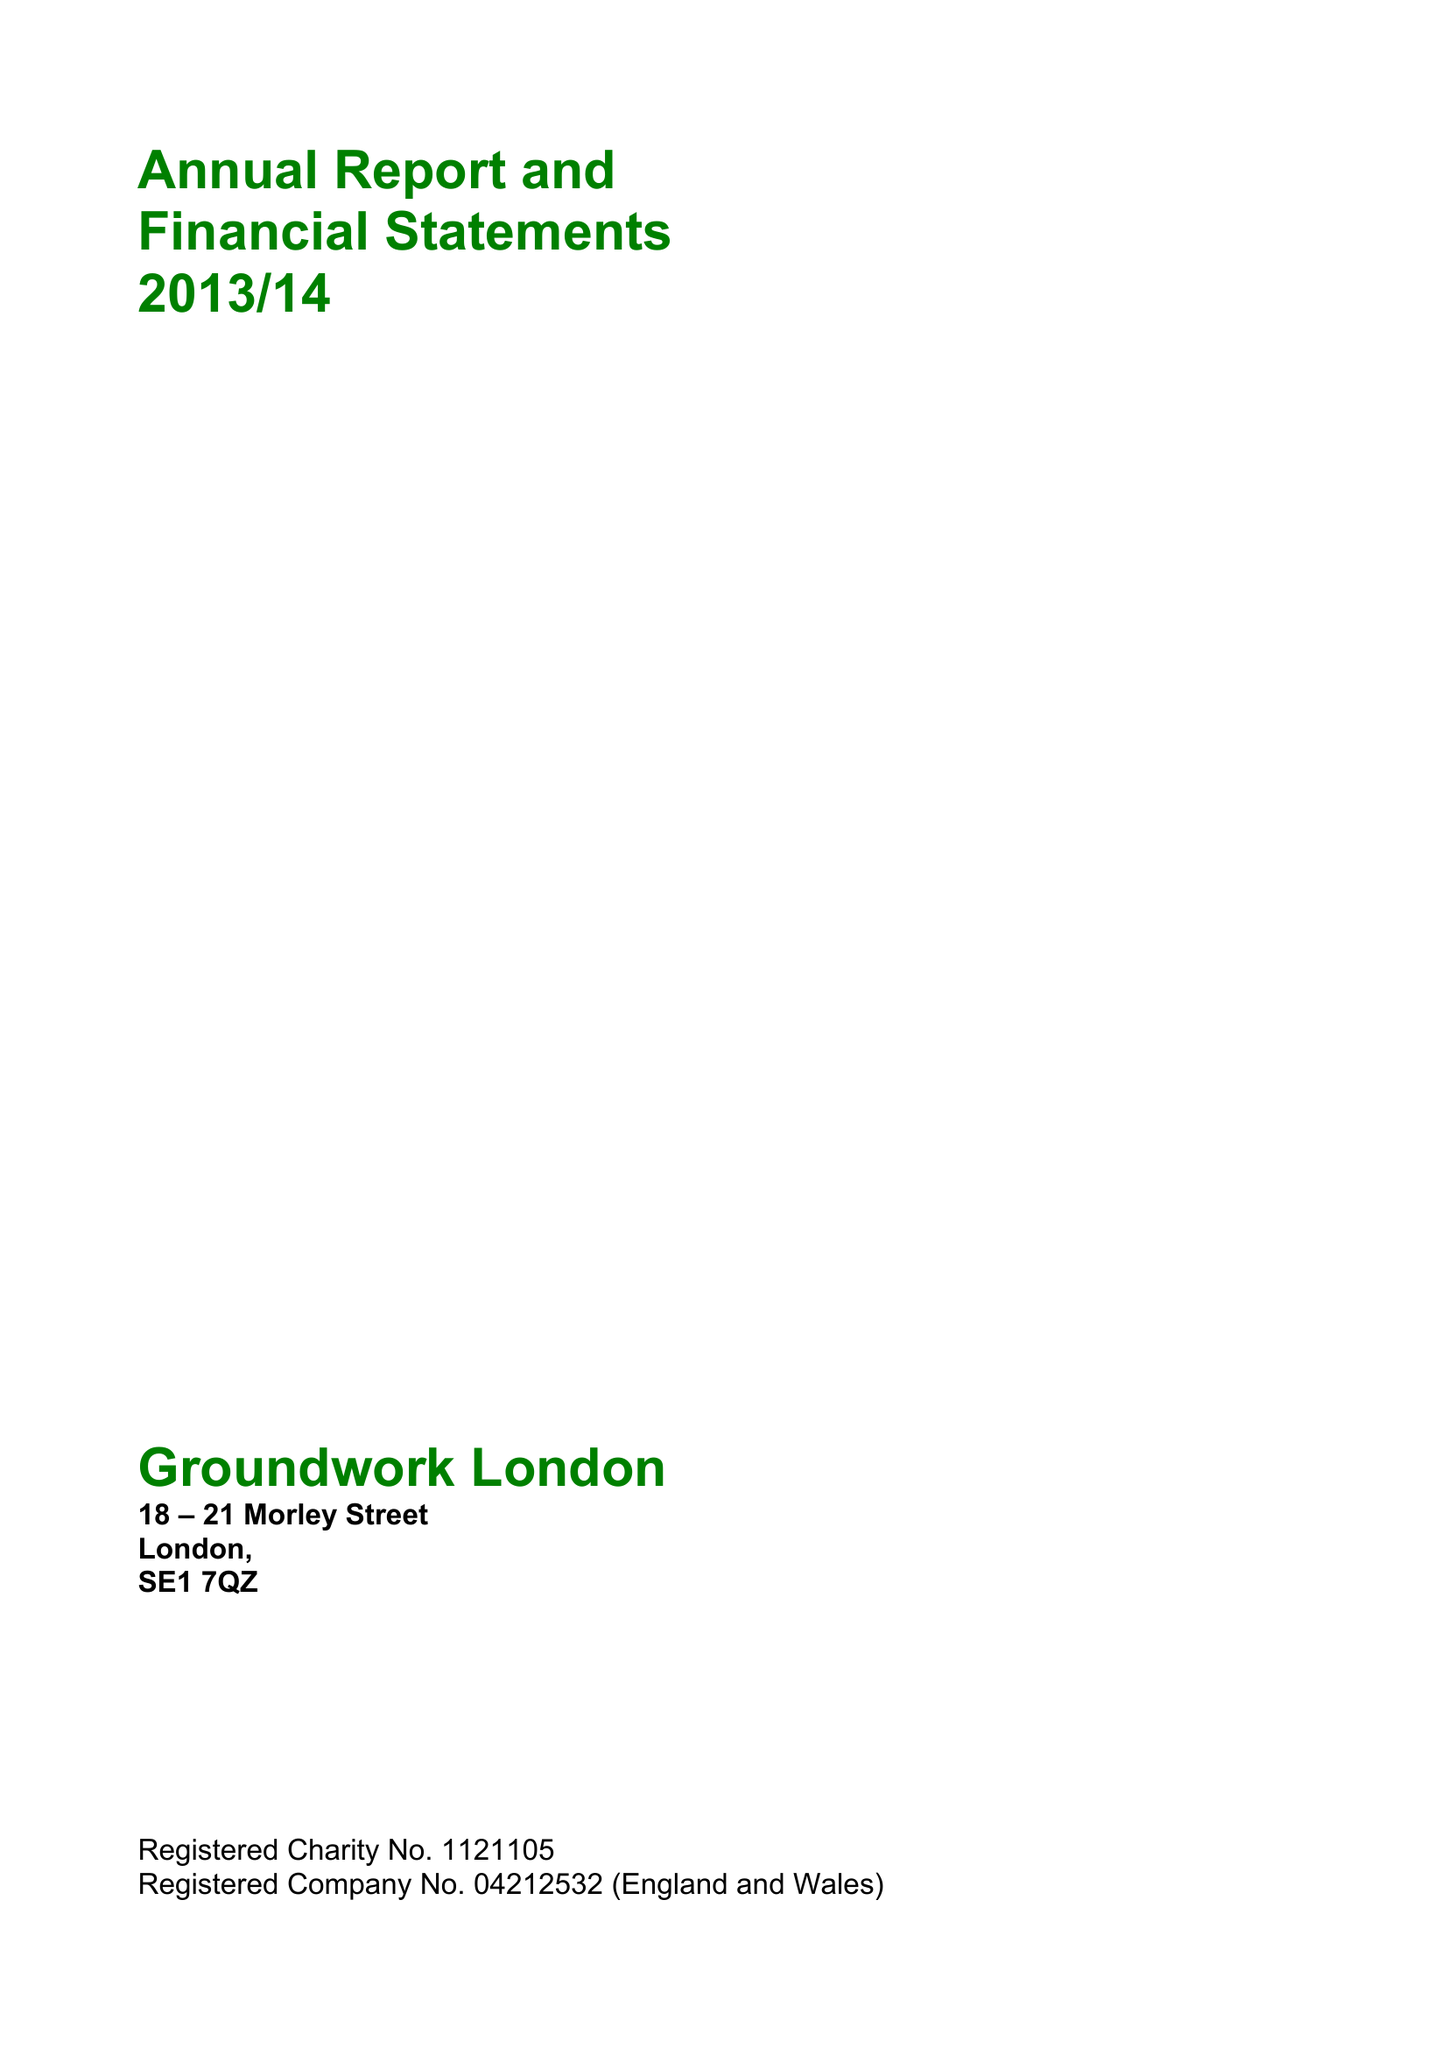What is the value for the address__post_town?
Answer the question using a single word or phrase. LONDON 